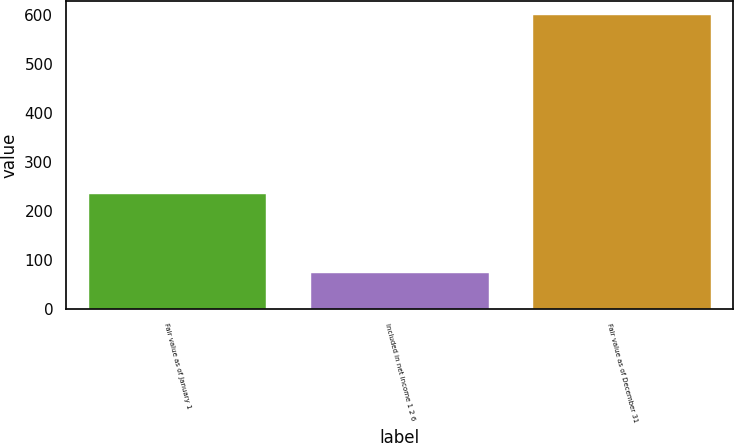Convert chart to OTSL. <chart><loc_0><loc_0><loc_500><loc_500><bar_chart><fcel>Fair value as of January 1<fcel>Included in net income 1 2 6<fcel>Fair value as of December 31<nl><fcel>236<fcel>74<fcel>600<nl></chart> 